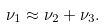<formula> <loc_0><loc_0><loc_500><loc_500>\nu _ { 1 } \approx \nu _ { 2 } + \nu _ { 3 } .</formula> 